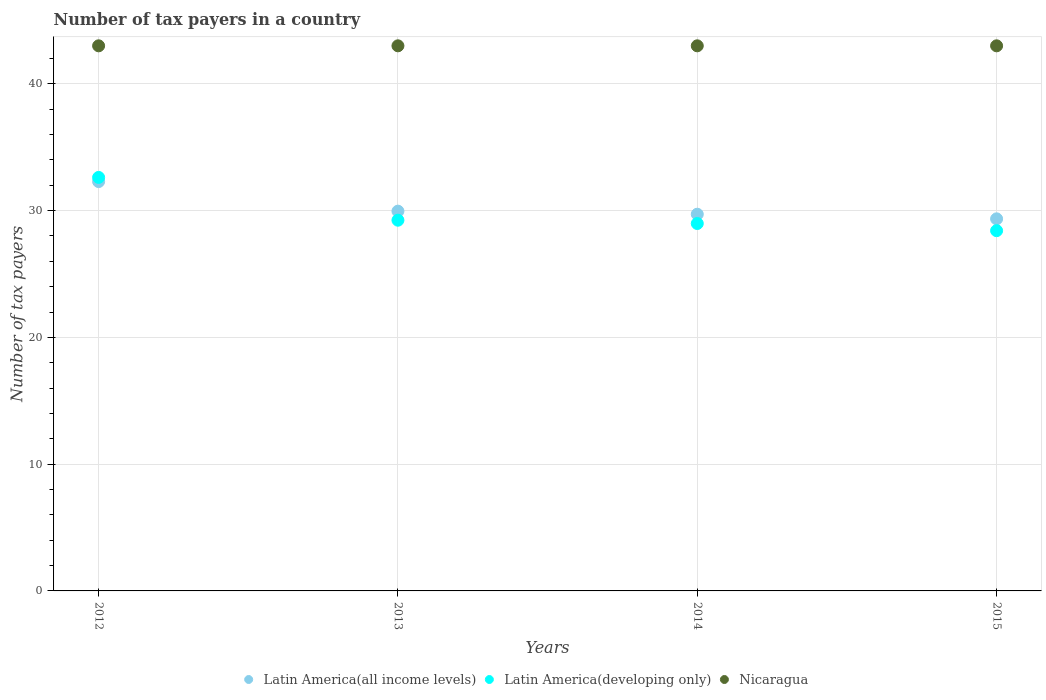Is the number of dotlines equal to the number of legend labels?
Offer a terse response. Yes. What is the number of tax payers in in Latin America(all income levels) in 2015?
Your response must be concise. 29.35. Across all years, what is the maximum number of tax payers in in Nicaragua?
Ensure brevity in your answer.  43. Across all years, what is the minimum number of tax payers in in Latin America(developing only)?
Ensure brevity in your answer.  28.42. In which year was the number of tax payers in in Nicaragua maximum?
Make the answer very short. 2012. In which year was the number of tax payers in in Nicaragua minimum?
Provide a succinct answer. 2012. What is the total number of tax payers in in Latin America(developing only) in the graph?
Provide a short and direct response. 119.26. What is the difference between the number of tax payers in in Nicaragua in 2013 and that in 2014?
Offer a terse response. 0. What is the difference between the number of tax payers in in Nicaragua in 2015 and the number of tax payers in in Latin America(all income levels) in 2013?
Make the answer very short. 13.04. What is the average number of tax payers in in Latin America(developing only) per year?
Provide a short and direct response. 29.82. In the year 2014, what is the difference between the number of tax payers in in Nicaragua and number of tax payers in in Latin America(developing only)?
Ensure brevity in your answer.  14.02. In how many years, is the number of tax payers in in Latin America(all income levels) greater than 8?
Give a very brief answer. 4. What is the ratio of the number of tax payers in in Nicaragua in 2012 to that in 2013?
Your response must be concise. 1. Is the difference between the number of tax payers in in Nicaragua in 2012 and 2013 greater than the difference between the number of tax payers in in Latin America(developing only) in 2012 and 2013?
Offer a very short reply. No. What is the difference between the highest and the lowest number of tax payers in in Latin America(all income levels)?
Provide a short and direct response. 2.94. In how many years, is the number of tax payers in in Latin America(all income levels) greater than the average number of tax payers in in Latin America(all income levels) taken over all years?
Ensure brevity in your answer.  1. Is the sum of the number of tax payers in in Latin America(all income levels) in 2013 and 2014 greater than the maximum number of tax payers in in Latin America(developing only) across all years?
Keep it short and to the point. Yes. Is it the case that in every year, the sum of the number of tax payers in in Latin America(all income levels) and number of tax payers in in Nicaragua  is greater than the number of tax payers in in Latin America(developing only)?
Provide a short and direct response. Yes. How many dotlines are there?
Provide a succinct answer. 3. How many years are there in the graph?
Provide a succinct answer. 4. What is the difference between two consecutive major ticks on the Y-axis?
Ensure brevity in your answer.  10. Are the values on the major ticks of Y-axis written in scientific E-notation?
Keep it short and to the point. No. Does the graph contain grids?
Your answer should be compact. Yes. How many legend labels are there?
Your response must be concise. 3. How are the legend labels stacked?
Ensure brevity in your answer.  Horizontal. What is the title of the graph?
Ensure brevity in your answer.  Number of tax payers in a country. Does "Central Europe" appear as one of the legend labels in the graph?
Offer a terse response. No. What is the label or title of the Y-axis?
Your answer should be compact. Number of tax payers. What is the Number of tax payers in Latin America(all income levels) in 2012?
Provide a short and direct response. 32.29. What is the Number of tax payers in Latin America(developing only) in 2012?
Provide a succinct answer. 32.62. What is the Number of tax payers in Latin America(all income levels) in 2013?
Provide a short and direct response. 29.96. What is the Number of tax payers of Latin America(developing only) in 2013?
Offer a terse response. 29.24. What is the Number of tax payers in Latin America(all income levels) in 2014?
Keep it short and to the point. 29.72. What is the Number of tax payers of Latin America(developing only) in 2014?
Keep it short and to the point. 28.98. What is the Number of tax payers of Nicaragua in 2014?
Provide a succinct answer. 43. What is the Number of tax payers in Latin America(all income levels) in 2015?
Give a very brief answer. 29.35. What is the Number of tax payers of Latin America(developing only) in 2015?
Keep it short and to the point. 28.42. Across all years, what is the maximum Number of tax payers in Latin America(all income levels)?
Your answer should be compact. 32.29. Across all years, what is the maximum Number of tax payers in Latin America(developing only)?
Provide a short and direct response. 32.62. Across all years, what is the minimum Number of tax payers in Latin America(all income levels)?
Make the answer very short. 29.35. Across all years, what is the minimum Number of tax payers in Latin America(developing only)?
Give a very brief answer. 28.42. Across all years, what is the minimum Number of tax payers in Nicaragua?
Your answer should be compact. 43. What is the total Number of tax payers in Latin America(all income levels) in the graph?
Make the answer very short. 121.31. What is the total Number of tax payers in Latin America(developing only) in the graph?
Give a very brief answer. 119.26. What is the total Number of tax payers in Nicaragua in the graph?
Your response must be concise. 172. What is the difference between the Number of tax payers of Latin America(all income levels) in 2012 and that in 2013?
Your response must be concise. 2.33. What is the difference between the Number of tax payers of Latin America(developing only) in 2012 and that in 2013?
Your answer should be very brief. 3.38. What is the difference between the Number of tax payers of Latin America(all income levels) in 2012 and that in 2014?
Your response must be concise. 2.58. What is the difference between the Number of tax payers of Latin America(developing only) in 2012 and that in 2014?
Your answer should be compact. 3.64. What is the difference between the Number of tax payers of Latin America(all income levels) in 2012 and that in 2015?
Provide a short and direct response. 2.94. What is the difference between the Number of tax payers of Latin America(developing only) in 2012 and that in 2015?
Make the answer very short. 4.2. What is the difference between the Number of tax payers of Latin America(all income levels) in 2013 and that in 2014?
Your answer should be very brief. 0.24. What is the difference between the Number of tax payers in Latin America(developing only) in 2013 and that in 2014?
Ensure brevity in your answer.  0.26. What is the difference between the Number of tax payers of Latin America(all income levels) in 2013 and that in 2015?
Your answer should be compact. 0.61. What is the difference between the Number of tax payers in Latin America(developing only) in 2013 and that in 2015?
Your answer should be compact. 0.83. What is the difference between the Number of tax payers in Latin America(all income levels) in 2014 and that in 2015?
Offer a very short reply. 0.36. What is the difference between the Number of tax payers in Latin America(developing only) in 2014 and that in 2015?
Offer a terse response. 0.57. What is the difference between the Number of tax payers in Latin America(all income levels) in 2012 and the Number of tax payers in Latin America(developing only) in 2013?
Offer a very short reply. 3.05. What is the difference between the Number of tax payers in Latin America(all income levels) in 2012 and the Number of tax payers in Nicaragua in 2013?
Your answer should be compact. -10.71. What is the difference between the Number of tax payers of Latin America(developing only) in 2012 and the Number of tax payers of Nicaragua in 2013?
Keep it short and to the point. -10.38. What is the difference between the Number of tax payers in Latin America(all income levels) in 2012 and the Number of tax payers in Latin America(developing only) in 2014?
Provide a short and direct response. 3.31. What is the difference between the Number of tax payers of Latin America(all income levels) in 2012 and the Number of tax payers of Nicaragua in 2014?
Your answer should be compact. -10.71. What is the difference between the Number of tax payers in Latin America(developing only) in 2012 and the Number of tax payers in Nicaragua in 2014?
Ensure brevity in your answer.  -10.38. What is the difference between the Number of tax payers in Latin America(all income levels) in 2012 and the Number of tax payers in Latin America(developing only) in 2015?
Give a very brief answer. 3.87. What is the difference between the Number of tax payers in Latin America(all income levels) in 2012 and the Number of tax payers in Nicaragua in 2015?
Provide a short and direct response. -10.71. What is the difference between the Number of tax payers in Latin America(developing only) in 2012 and the Number of tax payers in Nicaragua in 2015?
Your response must be concise. -10.38. What is the difference between the Number of tax payers in Latin America(all income levels) in 2013 and the Number of tax payers in Nicaragua in 2014?
Provide a short and direct response. -13.04. What is the difference between the Number of tax payers in Latin America(developing only) in 2013 and the Number of tax payers in Nicaragua in 2014?
Your answer should be very brief. -13.76. What is the difference between the Number of tax payers of Latin America(all income levels) in 2013 and the Number of tax payers of Latin America(developing only) in 2015?
Your answer should be compact. 1.54. What is the difference between the Number of tax payers in Latin America(all income levels) in 2013 and the Number of tax payers in Nicaragua in 2015?
Offer a very short reply. -13.04. What is the difference between the Number of tax payers of Latin America(developing only) in 2013 and the Number of tax payers of Nicaragua in 2015?
Give a very brief answer. -13.76. What is the difference between the Number of tax payers of Latin America(all income levels) in 2014 and the Number of tax payers of Latin America(developing only) in 2015?
Provide a succinct answer. 1.3. What is the difference between the Number of tax payers of Latin America(all income levels) in 2014 and the Number of tax payers of Nicaragua in 2015?
Ensure brevity in your answer.  -13.28. What is the difference between the Number of tax payers of Latin America(developing only) in 2014 and the Number of tax payers of Nicaragua in 2015?
Provide a short and direct response. -14.02. What is the average Number of tax payers of Latin America(all income levels) per year?
Your answer should be compact. 30.33. What is the average Number of tax payers of Latin America(developing only) per year?
Keep it short and to the point. 29.82. In the year 2012, what is the difference between the Number of tax payers of Latin America(all income levels) and Number of tax payers of Latin America(developing only)?
Provide a succinct answer. -0.33. In the year 2012, what is the difference between the Number of tax payers of Latin America(all income levels) and Number of tax payers of Nicaragua?
Offer a very short reply. -10.71. In the year 2012, what is the difference between the Number of tax payers in Latin America(developing only) and Number of tax payers in Nicaragua?
Ensure brevity in your answer.  -10.38. In the year 2013, what is the difference between the Number of tax payers in Latin America(all income levels) and Number of tax payers in Latin America(developing only)?
Offer a terse response. 0.71. In the year 2013, what is the difference between the Number of tax payers in Latin America(all income levels) and Number of tax payers in Nicaragua?
Give a very brief answer. -13.04. In the year 2013, what is the difference between the Number of tax payers in Latin America(developing only) and Number of tax payers in Nicaragua?
Offer a very short reply. -13.76. In the year 2014, what is the difference between the Number of tax payers of Latin America(all income levels) and Number of tax payers of Latin America(developing only)?
Make the answer very short. 0.73. In the year 2014, what is the difference between the Number of tax payers in Latin America(all income levels) and Number of tax payers in Nicaragua?
Make the answer very short. -13.28. In the year 2014, what is the difference between the Number of tax payers in Latin America(developing only) and Number of tax payers in Nicaragua?
Make the answer very short. -14.02. In the year 2015, what is the difference between the Number of tax payers in Latin America(all income levels) and Number of tax payers in Latin America(developing only)?
Your answer should be very brief. 0.93. In the year 2015, what is the difference between the Number of tax payers of Latin America(all income levels) and Number of tax payers of Nicaragua?
Your answer should be compact. -13.65. In the year 2015, what is the difference between the Number of tax payers in Latin America(developing only) and Number of tax payers in Nicaragua?
Offer a terse response. -14.58. What is the ratio of the Number of tax payers in Latin America(all income levels) in 2012 to that in 2013?
Make the answer very short. 1.08. What is the ratio of the Number of tax payers in Latin America(developing only) in 2012 to that in 2013?
Provide a short and direct response. 1.12. What is the ratio of the Number of tax payers of Nicaragua in 2012 to that in 2013?
Your answer should be very brief. 1. What is the ratio of the Number of tax payers in Latin America(all income levels) in 2012 to that in 2014?
Offer a very short reply. 1.09. What is the ratio of the Number of tax payers in Latin America(developing only) in 2012 to that in 2014?
Make the answer very short. 1.13. What is the ratio of the Number of tax payers of Latin America(all income levels) in 2012 to that in 2015?
Keep it short and to the point. 1.1. What is the ratio of the Number of tax payers of Latin America(developing only) in 2012 to that in 2015?
Ensure brevity in your answer.  1.15. What is the ratio of the Number of tax payers of Latin America(all income levels) in 2013 to that in 2014?
Keep it short and to the point. 1.01. What is the ratio of the Number of tax payers in Nicaragua in 2013 to that in 2014?
Your answer should be compact. 1. What is the ratio of the Number of tax payers in Latin America(all income levels) in 2013 to that in 2015?
Provide a succinct answer. 1.02. What is the ratio of the Number of tax payers of Latin America(developing only) in 2013 to that in 2015?
Your answer should be very brief. 1.03. What is the ratio of the Number of tax payers in Nicaragua in 2013 to that in 2015?
Your answer should be very brief. 1. What is the ratio of the Number of tax payers in Latin America(all income levels) in 2014 to that in 2015?
Provide a short and direct response. 1.01. What is the ratio of the Number of tax payers of Latin America(developing only) in 2014 to that in 2015?
Your response must be concise. 1.02. What is the difference between the highest and the second highest Number of tax payers in Latin America(all income levels)?
Your answer should be compact. 2.33. What is the difference between the highest and the second highest Number of tax payers of Latin America(developing only)?
Provide a short and direct response. 3.38. What is the difference between the highest and the second highest Number of tax payers of Nicaragua?
Offer a terse response. 0. What is the difference between the highest and the lowest Number of tax payers of Latin America(all income levels)?
Ensure brevity in your answer.  2.94. What is the difference between the highest and the lowest Number of tax payers of Latin America(developing only)?
Give a very brief answer. 4.2. 